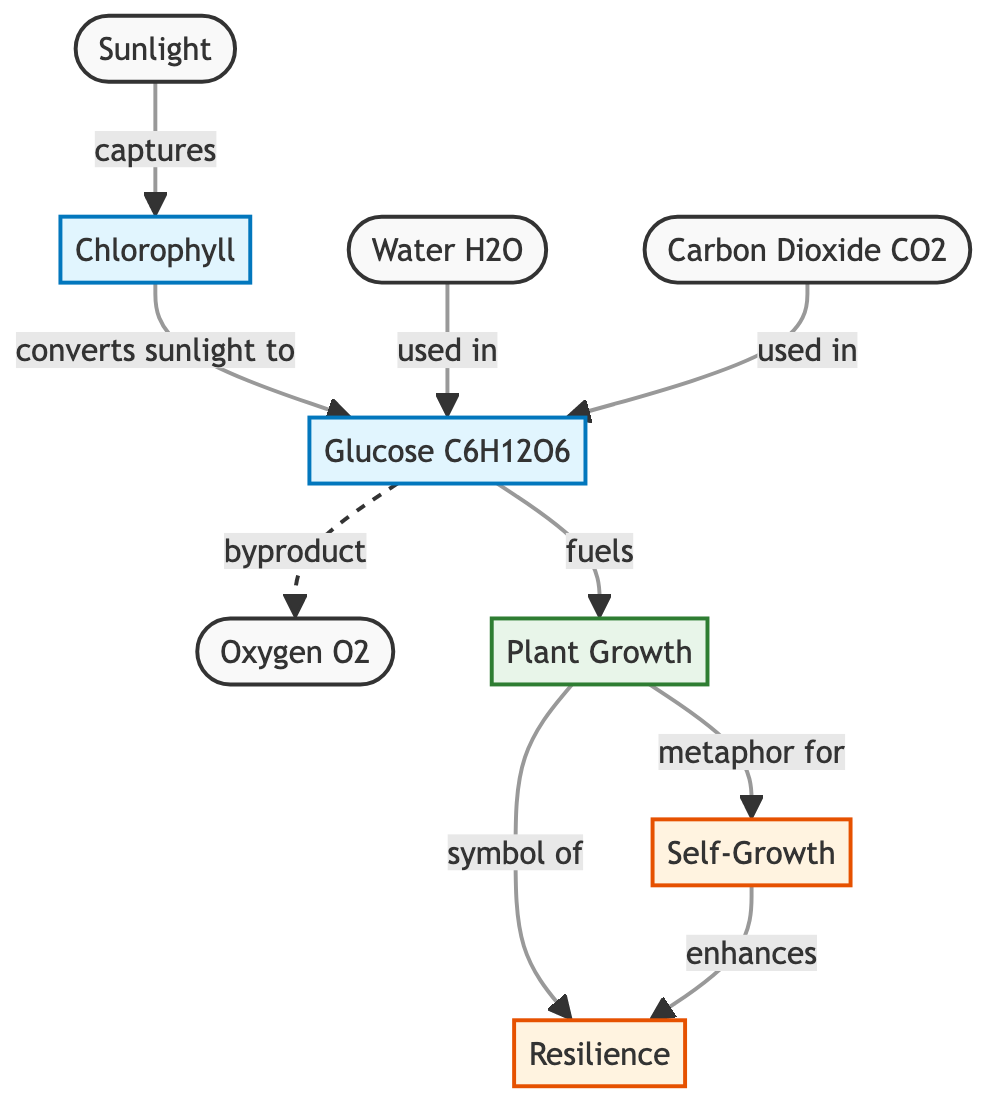What is the first element in the diagram? The first element illustrated in the diagram is "Sunlight," which is positioned at the top and initiates the process of photosynthesis.
Answer: Sunlight How many nodes are represented in the diagram? The diagram contains a total of eight nodes: Sunlight, Chlorophyll, Water, Carbon Dioxide, Glucose, Oxygen, Plant Growth, Self-Growth, and Resilience, which can be counted by visually inspecting each step.
Answer: Eight What does chlorophyll convert sunlight into? According to the diagram, chlorophyll converts sunlight into glucose, which is a central product of the photosynthesis process.
Answer: Glucose What is produced as a byproduct of glucose? The diagram indicates that oxygen is produced as a byproduct of glucose during the photosynthesis process, detailing the outcomes of the process.
Answer: Oxygen How does plant growth relate to self-growth? The diagram shows that plant growth serves as a metaphor for self-growth, illustrating a conceptual connection between the two ideas through the arrows that indicate relationships.
Answer: Metaphor for self-growth What enhances resilience according to the diagram? The relationship illustrated in the diagram indicates that self-growth enhances resilience, linking the two concepts together visually in the flow of the diagram.
Answer: Enhances What role does carbon dioxide play in the diagram? The diagram shows that carbon dioxide is used in the production of glucose, highlighting its importance as a raw material in the photosynthesis process.
Answer: Used in glucose How do plant growth and resilience relate? The diagram specifies that plant growth symbolizes resilience, establishing a symbolic connection that links the biological process to emotional concepts.
Answer: Symbol of resilience What is the connection between glucose and plant growth? Glucose is depicted in the diagram as a fuel for plant growth, indicating a direct relationship where glucose is essential for the energy needed for plant development.
Answer: Fuels 